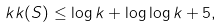<formula> <loc_0><loc_0><loc_500><loc_500>\ k k ( S ) \leq \log k + \log \log k + 5 ,</formula> 